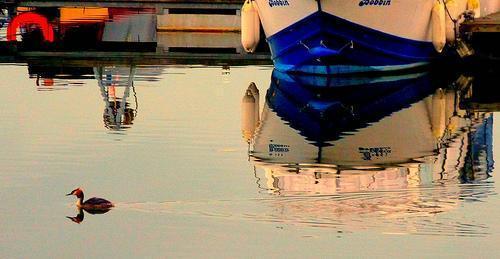How many ducks are in the water?
Give a very brief answer. 1. 